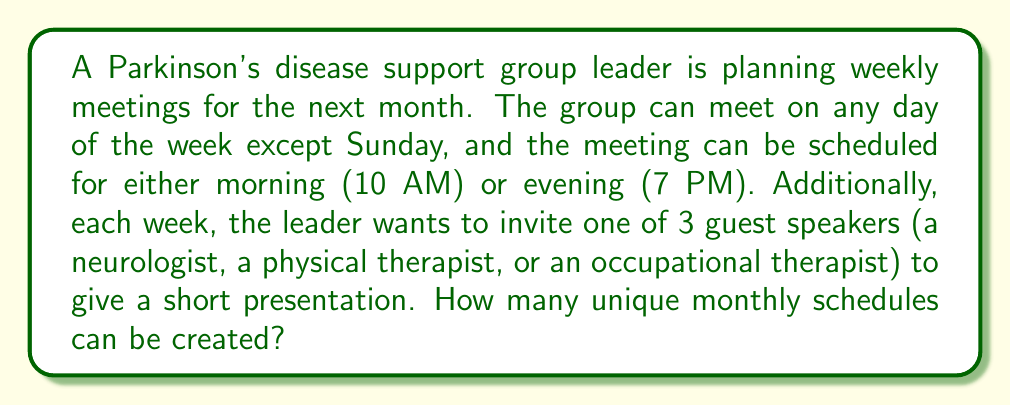What is the answer to this math problem? Let's break this down step-by-step:

1) First, we need to determine the number of options for each week:

   a) Days available: 6 (Monday to Saturday)
   b) Time slots: 2 (10 AM or 7 PM)
   c) Guest speakers: 3 (neurologist, physical therapist, occupational therapist)

2) For each week, we can calculate the number of possibilities:
   $6 \text{ days} \times 2 \text{ time slots} \times 3 \text{ speakers} = 36$ options per week

3) Now, we need to consider that this schedule is for a month, which typically has 4 weeks.

4) Since each week's choice is independent of the others, we can use the multiplication principle of combinatorics.

5) The total number of unique monthly schedules is:
   $36 \text{ options for week 1} \times 36 \text{ options for week 2} \times 36 \text{ options for week 3} \times 36 \text{ options for week 4}$

6) This can be written as: $36^4$

7) Calculating this:
   $36^4 = 1,679,616$

Therefore, the support group leader can create 1,679,616 unique monthly schedules.
Answer: $1,679,616$ 